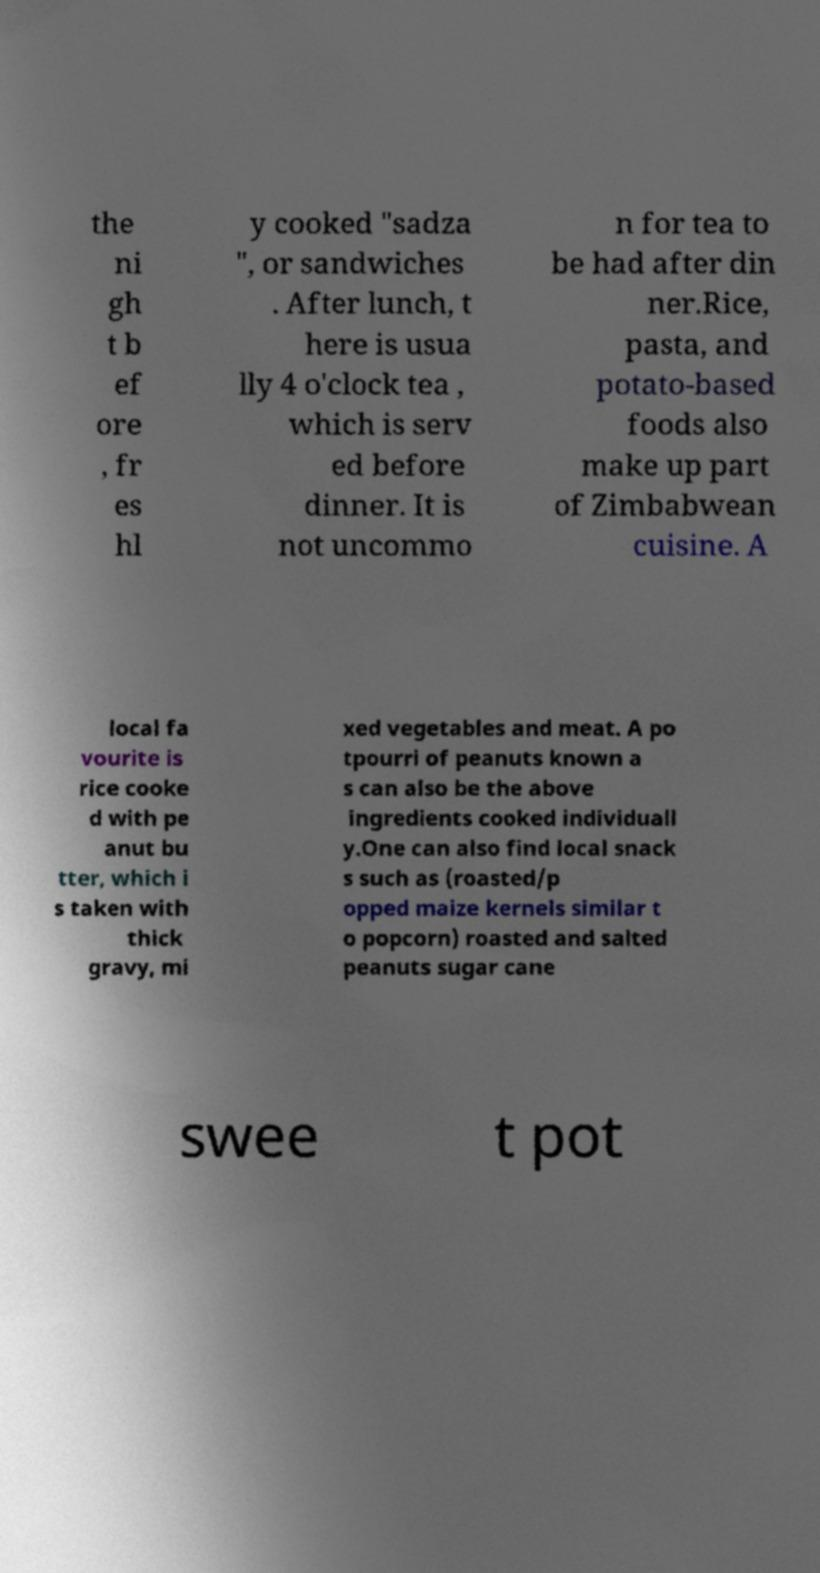Can you read and provide the text displayed in the image?This photo seems to have some interesting text. Can you extract and type it out for me? the ni gh t b ef ore , fr es hl y cooked "sadza ", or sandwiches . After lunch, t here is usua lly 4 o'clock tea , which is serv ed before dinner. It is not uncommo n for tea to be had after din ner.Rice, pasta, and potato-based foods also make up part of Zimbabwean cuisine. A local fa vourite is rice cooke d with pe anut bu tter, which i s taken with thick gravy, mi xed vegetables and meat. A po tpourri of peanuts known a s can also be the above ingredients cooked individuall y.One can also find local snack s such as (roasted/p opped maize kernels similar t o popcorn) roasted and salted peanuts sugar cane swee t pot 